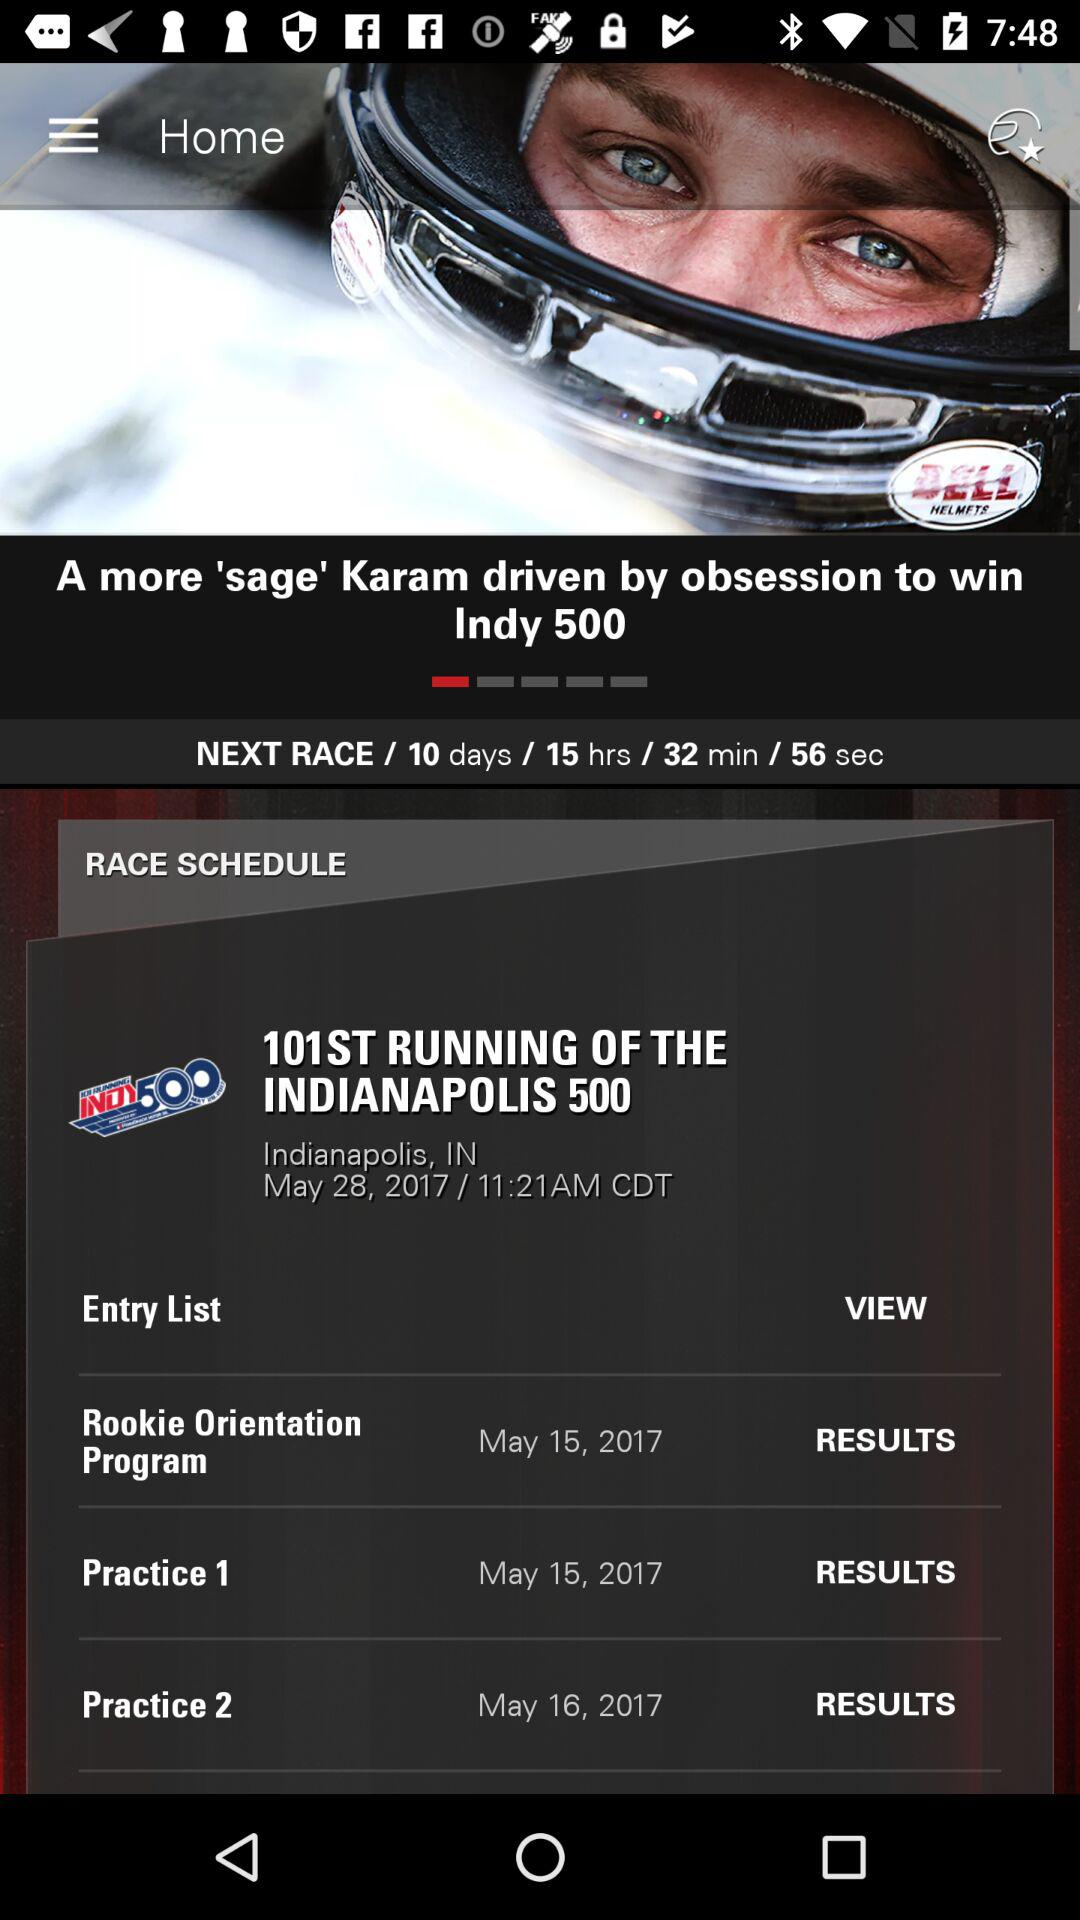When will the next race happen? The next race will happen in 10 days, 15 hours, 32 minutes, and 56 seconds. 